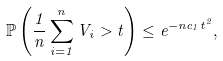Convert formula to latex. <formula><loc_0><loc_0><loc_500><loc_500>\mathbb { P } \left ( \frac { 1 } { n } \sum _ { i = 1 } ^ { n } V _ { i } > t \right ) \leq e ^ { - n c _ { 1 } t ^ { 2 } } ,</formula> 